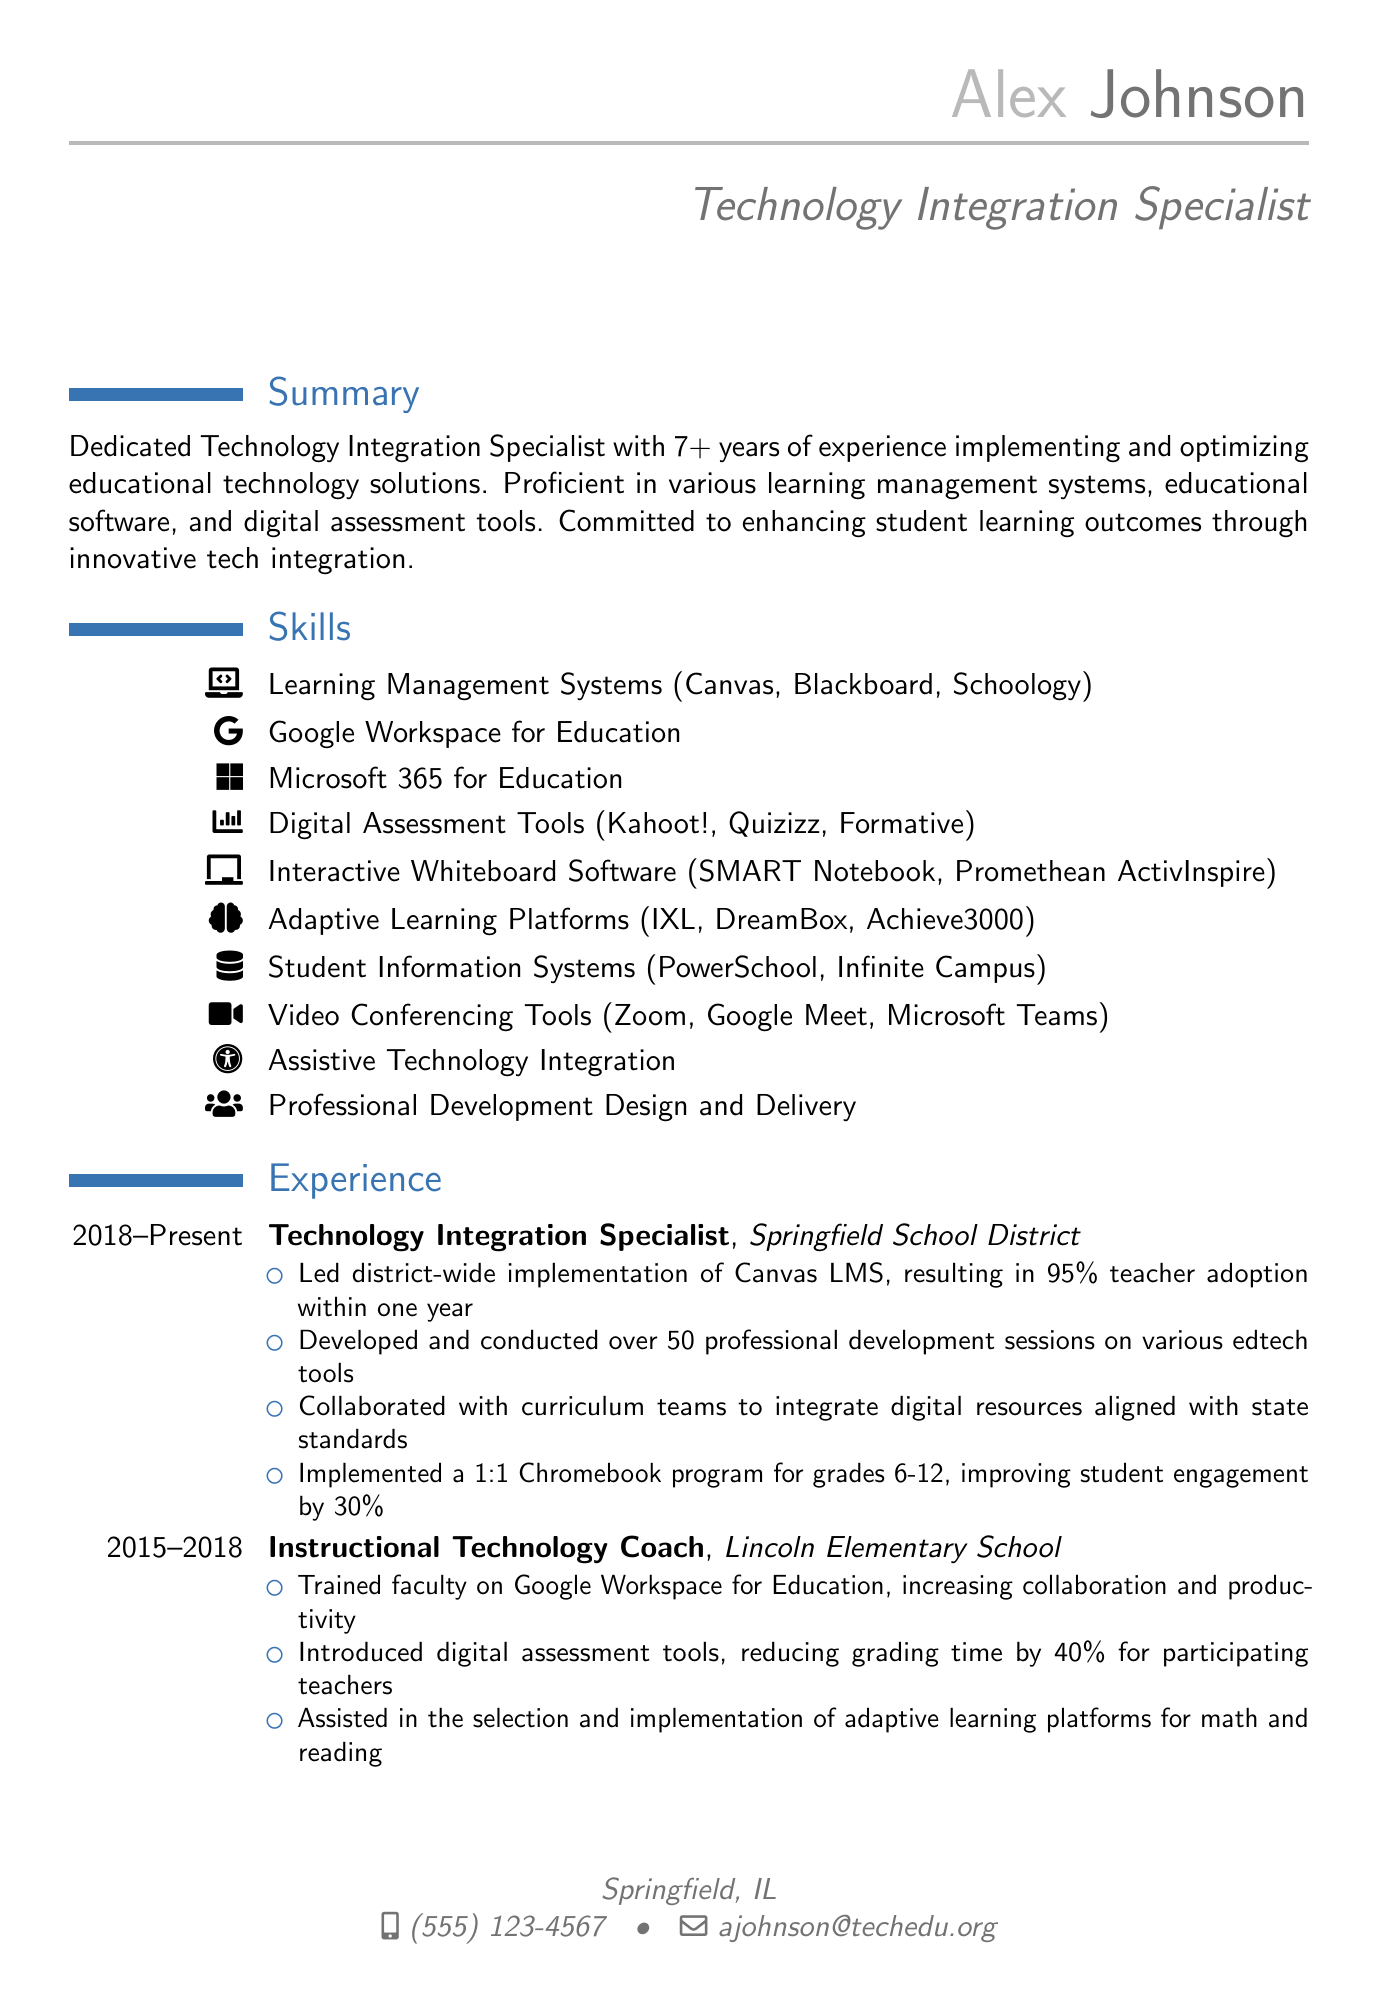What is the name of the individual? The name appears in the header section of the resume, indicating the person's identity.
Answer: Alex Johnson What is the location listed in the contact information? The location is specified in the contact section of the resume, showing where the individual is based.
Answer: Springfield, IL How many years of experience does Alex Johnson have? The summary section states the total years of experience Alex has in the field of technology integration.
Answer: 7+ What are the first three listed digital assessment tools? The skills section provides a list of digital assessment tools used by Alex, which can be directly retrieved.
Answer: Kahoot!, Quizizz, Formative What is the title of the most recent position held by Alex Johnson? The experience section indicates the current job title held by Alex, showing their current role.
Answer: Technology Integration Specialist How much did student engagement improve after implementing the 1:1 Chromebook program? The experience section cites a percentage that indicates the level of improvement in student engagement.
Answer: 30% Which institution did Alex Johnson obtain their M.Ed. from? The education section cites the university attended for the degree, providing confirmation of the educational background.
Answer: University of Illinois What certification does Alex have related to Apple products? The certifications section lists the certification related to Apple, which shows the individual's qualifications.
Answer: Apple Teacher How many professional development sessions did Alex conduct? The experience section highlights a specific number of sessions delivered by Alex, showing their contributions in professional development.
Answer: 50 